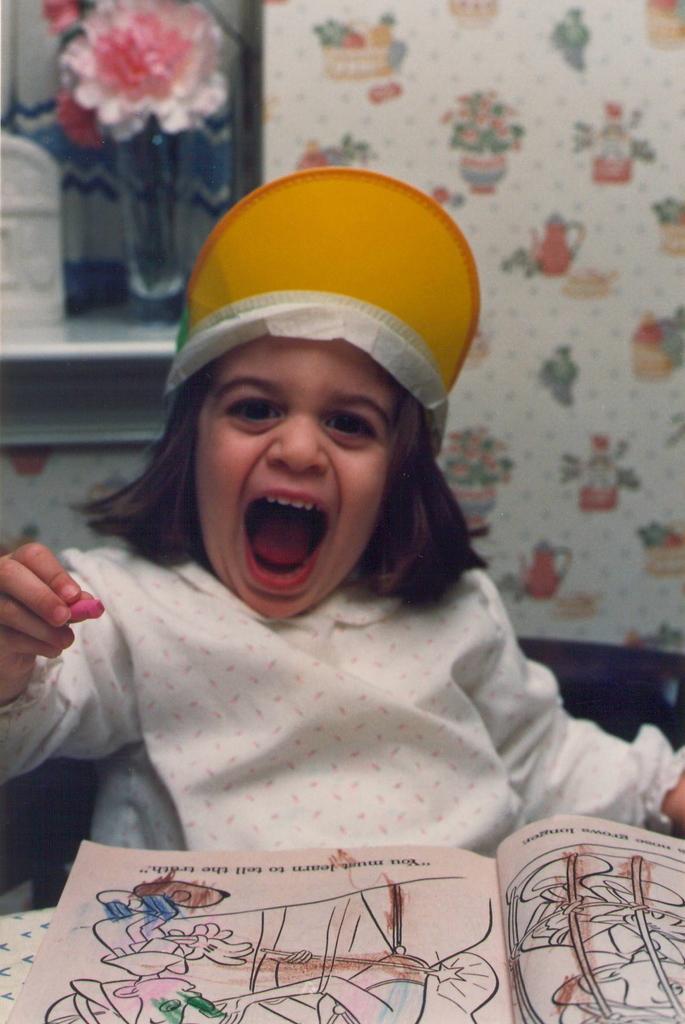Can you describe this image briefly? In this image there is a girl wearing a cap and holding a crayon, there is a drawing book on the table, behind her there is a flower vase on the wall. 